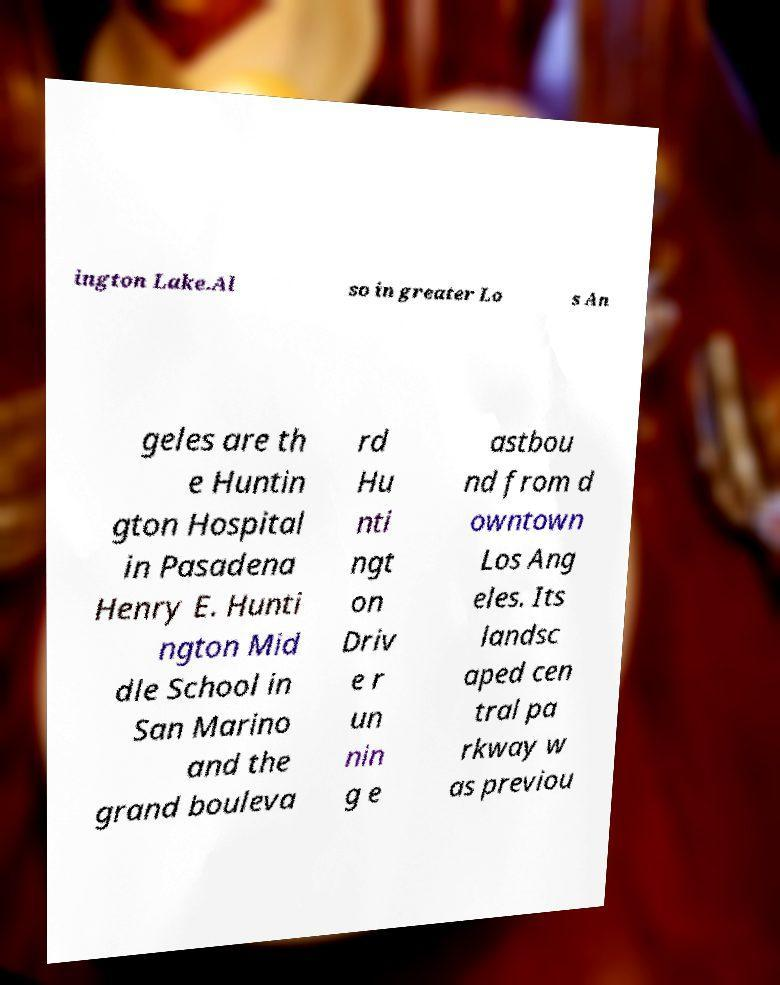Please read and relay the text visible in this image. What does it say? ington Lake.Al so in greater Lo s An geles are th e Huntin gton Hospital in Pasadena Henry E. Hunti ngton Mid dle School in San Marino and the grand bouleva rd Hu nti ngt on Driv e r un nin g e astbou nd from d owntown Los Ang eles. Its landsc aped cen tral pa rkway w as previou 